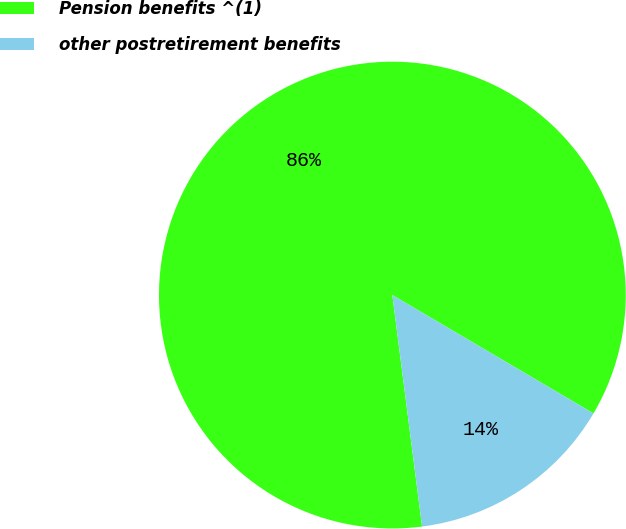Convert chart to OTSL. <chart><loc_0><loc_0><loc_500><loc_500><pie_chart><fcel>Pension benefits ^(1)<fcel>other postretirement benefits<nl><fcel>85.5%<fcel>14.5%<nl></chart> 